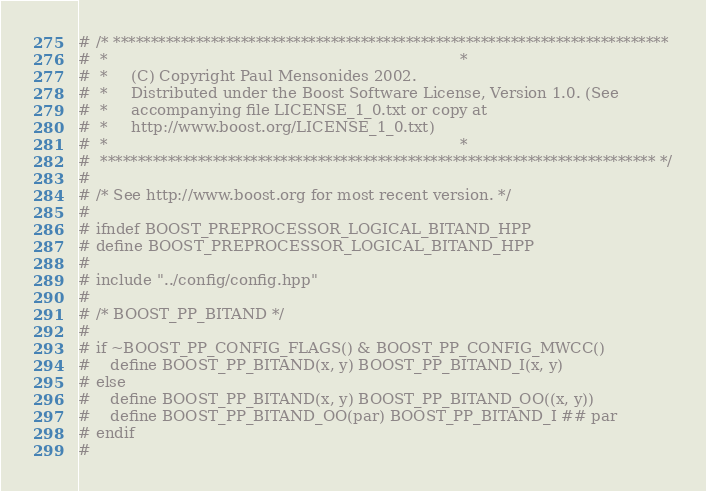<code> <loc_0><loc_0><loc_500><loc_500><_C++_># /* **************************************************************************
#  *                                                                          *
#  *     (C) Copyright Paul Mensonides 2002.
#  *     Distributed under the Boost Software License, Version 1.0. (See
#  *     accompanying file LICENSE_1_0.txt or copy at
#  *     http://www.boost.org/LICENSE_1_0.txt)
#  *                                                                          *
#  ************************************************************************** */
#
# /* See http://www.boost.org for most recent version. */
#
# ifndef BOOST_PREPROCESSOR_LOGICAL_BITAND_HPP
# define BOOST_PREPROCESSOR_LOGICAL_BITAND_HPP
#
# include "../config/config.hpp"
#
# /* BOOST_PP_BITAND */
#
# if ~BOOST_PP_CONFIG_FLAGS() & BOOST_PP_CONFIG_MWCC()
#    define BOOST_PP_BITAND(x, y) BOOST_PP_BITAND_I(x, y)
# else
#    define BOOST_PP_BITAND(x, y) BOOST_PP_BITAND_OO((x, y))
#    define BOOST_PP_BITAND_OO(par) BOOST_PP_BITAND_I ## par
# endif
#</code> 